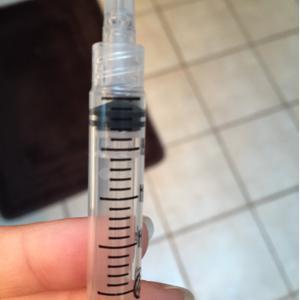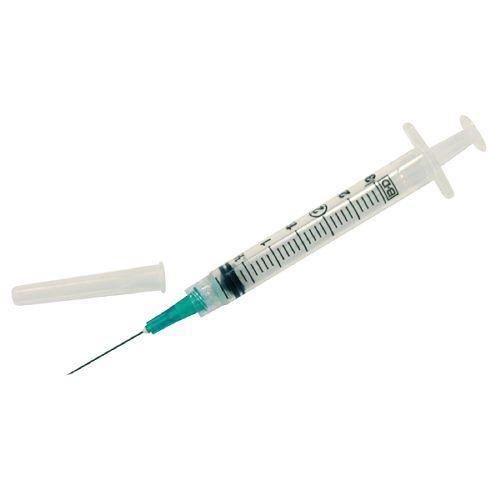The first image is the image on the left, the second image is the image on the right. Given the left and right images, does the statement "One of the syringes has a green tip." hold true? Answer yes or no. Yes. The first image is the image on the left, the second image is the image on the right. Analyze the images presented: Is the assertion "At least one photo contains a syringe with a green tip." valid? Answer yes or no. Yes. 